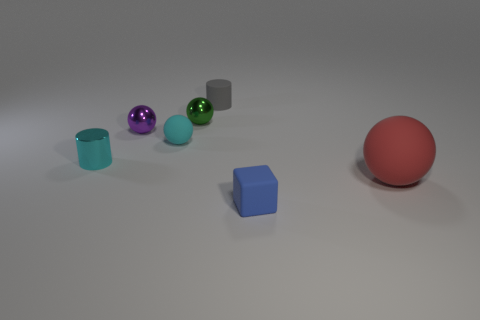Add 2 big brown spheres. How many objects exist? 9 Subtract all cylinders. How many objects are left? 5 Subtract 0 green cubes. How many objects are left? 7 Subtract all tiny purple objects. Subtract all tiny purple metal balls. How many objects are left? 5 Add 7 cylinders. How many cylinders are left? 9 Add 5 purple rubber spheres. How many purple rubber spheres exist? 5 